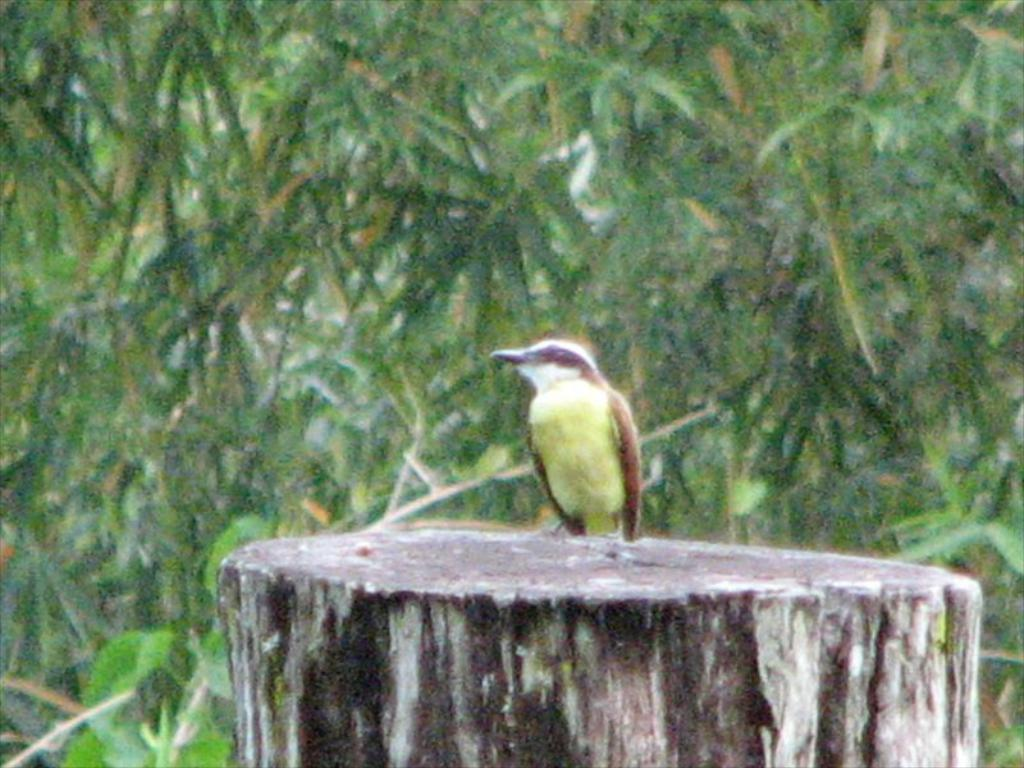What is at the base of the image? There is a stem at the bottom of the image. What can be seen on the stem? A bird is present on the stem. What type of vegetation is visible in the background? There are trees visible behind the bird. How would you describe the appearance of the background? The background of the image is blurred. What type of mint can be seen growing near the bird in the image? There is no mint present in the image; it only features a stem with a bird on it and trees in the background. 